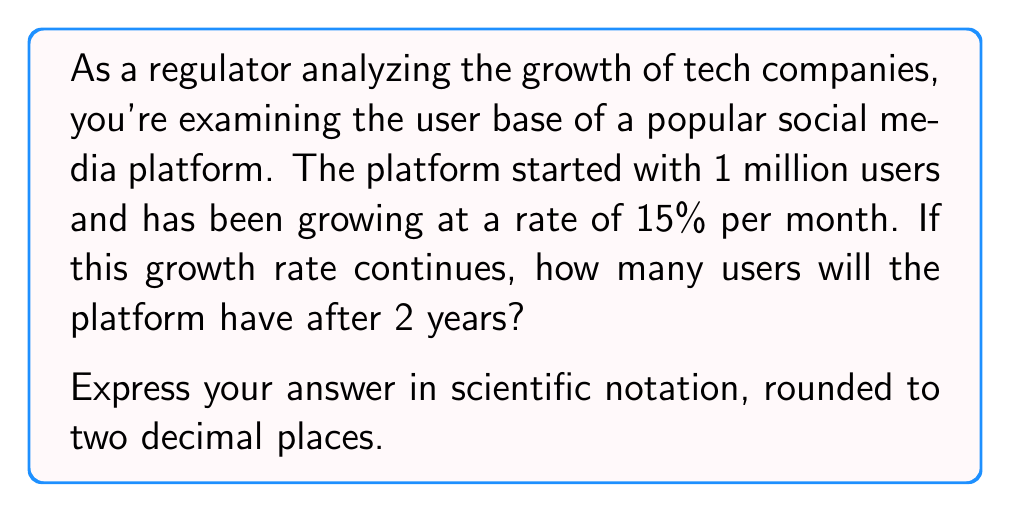Give your solution to this math problem. To solve this problem, we'll use the exponential growth formula:

$$A = P(1 + r)^t$$

Where:
$A$ = Final amount
$P$ = Initial amount (principal)
$r$ = Growth rate (as a decimal)
$t$ = Time period

Given:
$P = 1,000,000$ (1 million users)
$r = 0.15$ (15% monthly growth rate)
$t = 24$ (2 years = 24 months)

Let's substitute these values into the formula:

$$A = 1,000,000(1 + 0.15)^{24}$$

Now, let's calculate:

1) First, simplify inside the parentheses:
   $$(1 + 0.15) = 1.15$$

2) Our equation now looks like this:
   $$A = 1,000,000(1.15)^{24}$$

3) Calculate $(1.15)^{24}$:
   $$(1.15)^{24} \approx 31.772$$

4) Multiply by 1,000,000:
   $$A = 1,000,000 \times 31.772 = 31,772,000$$

5) Express in scientific notation:
   $$A = 3.1772 \times 10^7$$

6) Round to two decimal places:
   $$A = 3.18 \times 10^7$$

Therefore, after 2 years, the platform will have approximately $3.18 \times 10^7$ users.
Answer: $3.18 \times 10^7$ users 